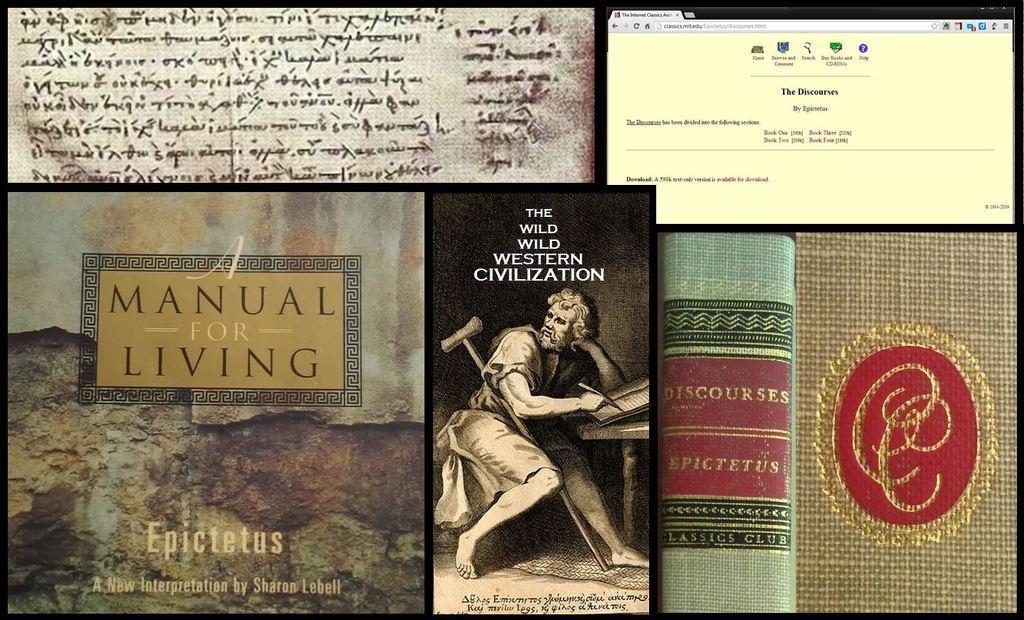What is the name of book by epictetus?
Keep it short and to the point. Manual for living. What is this manual for?
Your answer should be compact. Living. 